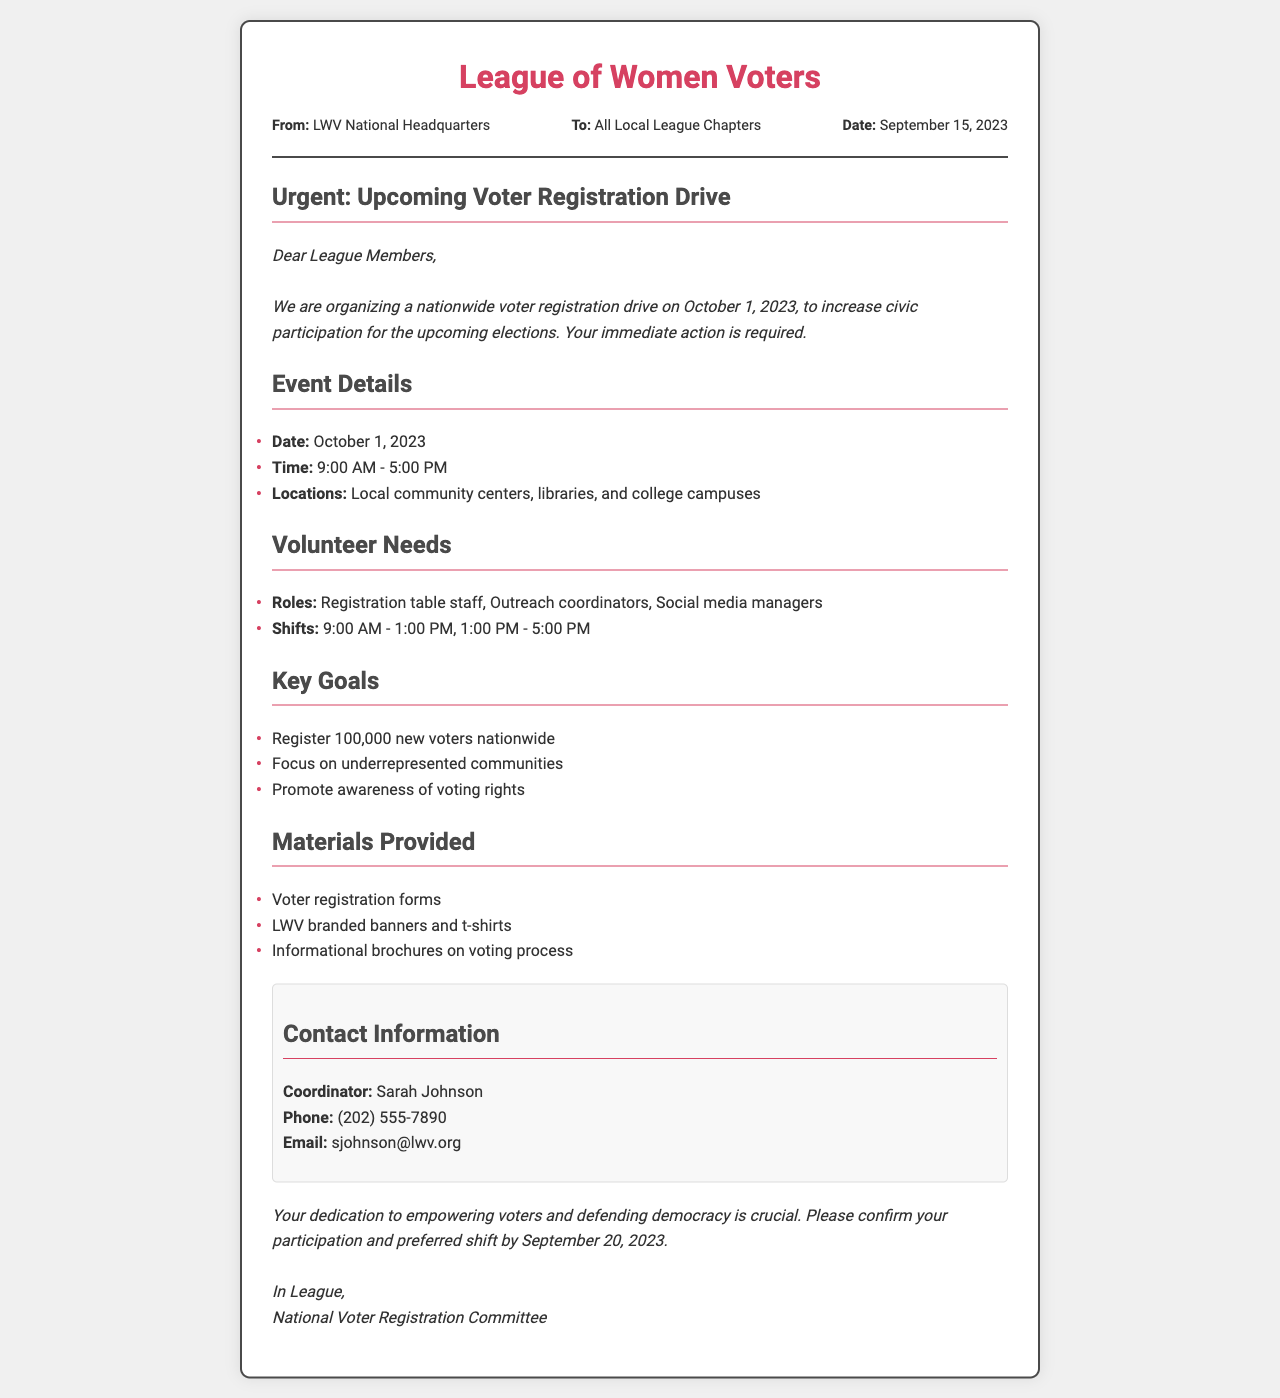what is the date of the voter registration drive? The document specifies the date of the voter registration drive as October 1, 2023.
Answer: October 1, 2023 who is the coordinator for the event? The document states that the coordinator's name is Sarah Johnson.
Answer: Sarah Johnson what are the operating hours for the voter registration drive? The document mentions the time for the event is from 9:00 AM to 5:00 PM.
Answer: 9:00 AM - 5:00 PM how many new voters does the drive aim to register? The document outlines that the goal is to register 100,000 new voters nationwide.
Answer: 100,000 what is one of the roles needed for volunteers? The document lists "Registration table staff" as one of the volunteer roles required.
Answer: Registration table staff what is one of the locations mentioned for the drive? The document states that local community centers are among the locations for the voter registration drive.
Answer: Local community centers by what date should participants confirm their shifts? The document specifies that confirmation of participation and preferred shift should be by September 20, 2023.
Answer: September 20, 2023 what type of document is this? The structure and content indicate that this is a fax communication regarding an event.
Answer: Fax what is a goal related to underrepresented communities? The document states that one of the goals is to focus on underrepresented communities.
Answer: Focus on underrepresented communities 